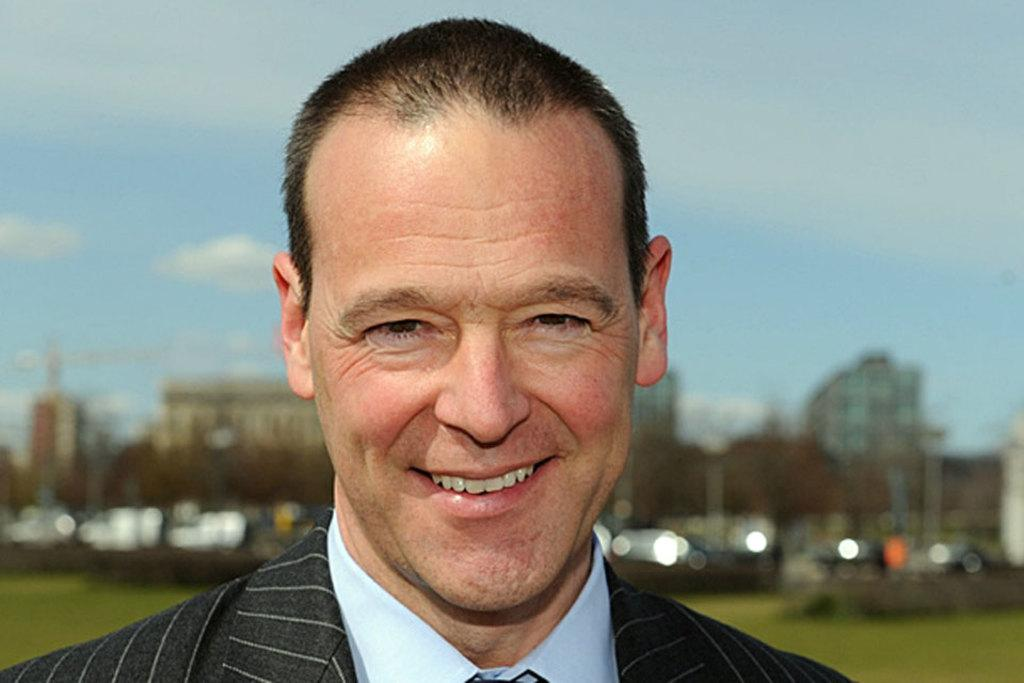Who is present in the image? There is a man in the image. What is the man doing in the image? The man is smiling in the image. What is the man wearing on his upper body? The man is wearing a blue shirt and a blazer. How is the background of the image depicted? The background of the man is blurred. What type of paste is the man using to improve his knowledge in the image? There is no paste or indication of knowledge improvement present in the image. 